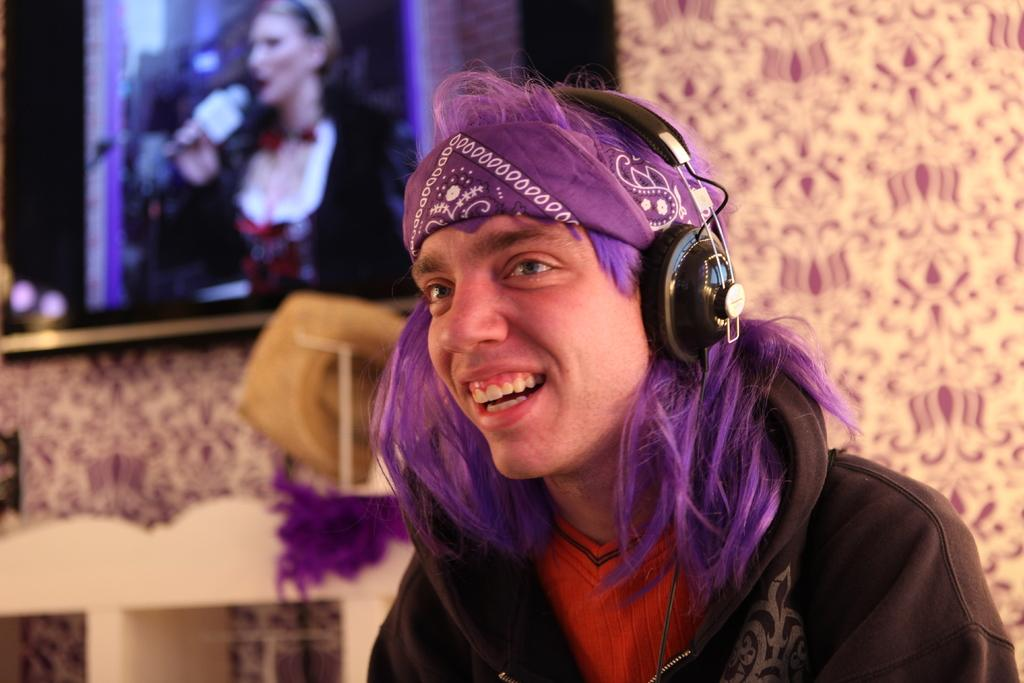Who is present in the image? There is a man in the image. What is the man wearing? The man is wearing a black jacket. What accessory is the man wearing? The man is wearing headphones. What is the color of the man's hair? The man's hair is purple. What can be seen in the background of the image? There is a wall in the background of the image, and a TV is fixed on the wall. How much wealth does the man in the image possess? There is no information about the man's wealth in the image. What type of copy machine is present in the image? There is no copy machine present in the image. 